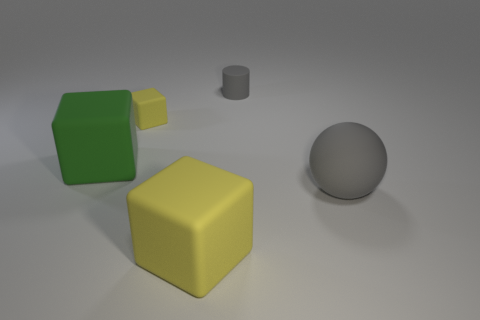Add 4 large gray matte things. How many objects exist? 9 Subtract all blocks. How many objects are left? 2 Subtract all tiny cylinders. Subtract all tiny yellow matte cubes. How many objects are left? 3 Add 4 yellow rubber cubes. How many yellow rubber cubes are left? 6 Add 1 tiny gray things. How many tiny gray things exist? 2 Subtract 0 brown balls. How many objects are left? 5 